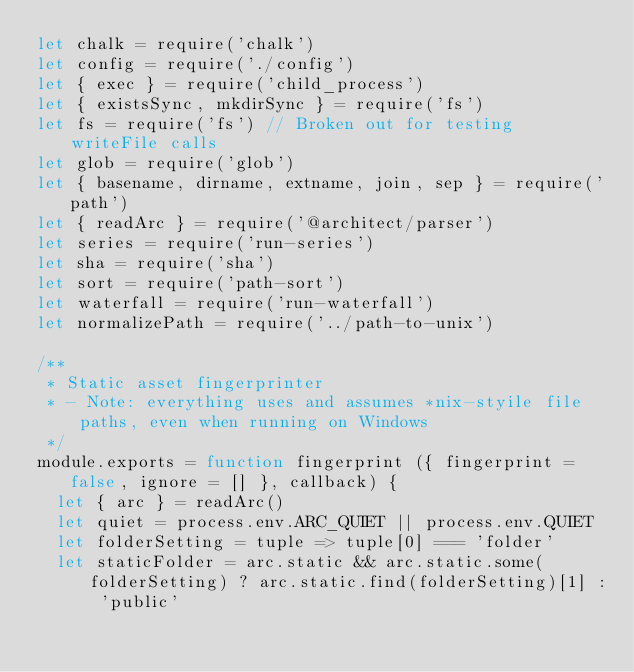Convert code to text. <code><loc_0><loc_0><loc_500><loc_500><_JavaScript_>let chalk = require('chalk')
let config = require('./config')
let { exec } = require('child_process')
let { existsSync, mkdirSync } = require('fs')
let fs = require('fs') // Broken out for testing writeFile calls
let glob = require('glob')
let { basename, dirname, extname, join, sep } = require('path')
let { readArc } = require('@architect/parser')
let series = require('run-series')
let sha = require('sha')
let sort = require('path-sort')
let waterfall = require('run-waterfall')
let normalizePath = require('../path-to-unix')

/**
 * Static asset fingerprinter
 * - Note: everything uses and assumes *nix-styile file paths, even when running on Windows
 */
module.exports = function fingerprint ({ fingerprint = false, ignore = [] }, callback) {
  let { arc } = readArc()
  let quiet = process.env.ARC_QUIET || process.env.QUIET
  let folderSetting = tuple => tuple[0] === 'folder'
  let staticFolder = arc.static && arc.static.some(folderSetting) ? arc.static.find(folderSetting)[1] : 'public'</code> 